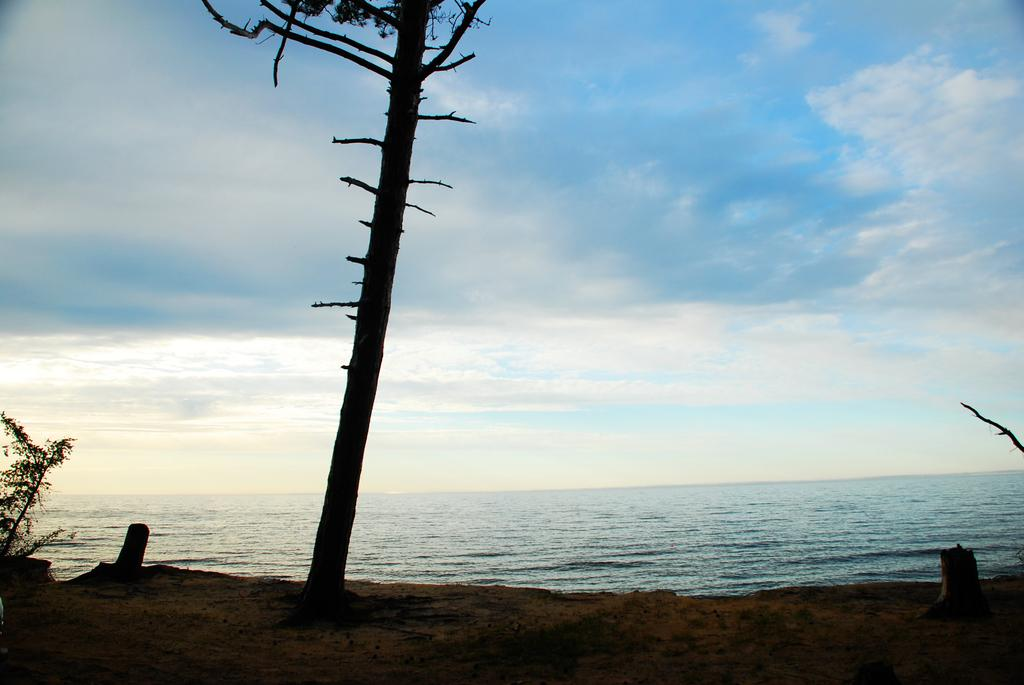What natural feature is depicted in the image? The image contains the ocean. What is located in the center of the image? There is a big tree in the center of the image. Where is the plant situated in the image? The plant is on the beach on the left side of the image. What is visible at the top of the image? The sky is visible at the top of the image. What can be seen in the sky? Clouds are present in the sky. How many chairs are placed on the farm in the image? There is no farm or chairs present in the image. 